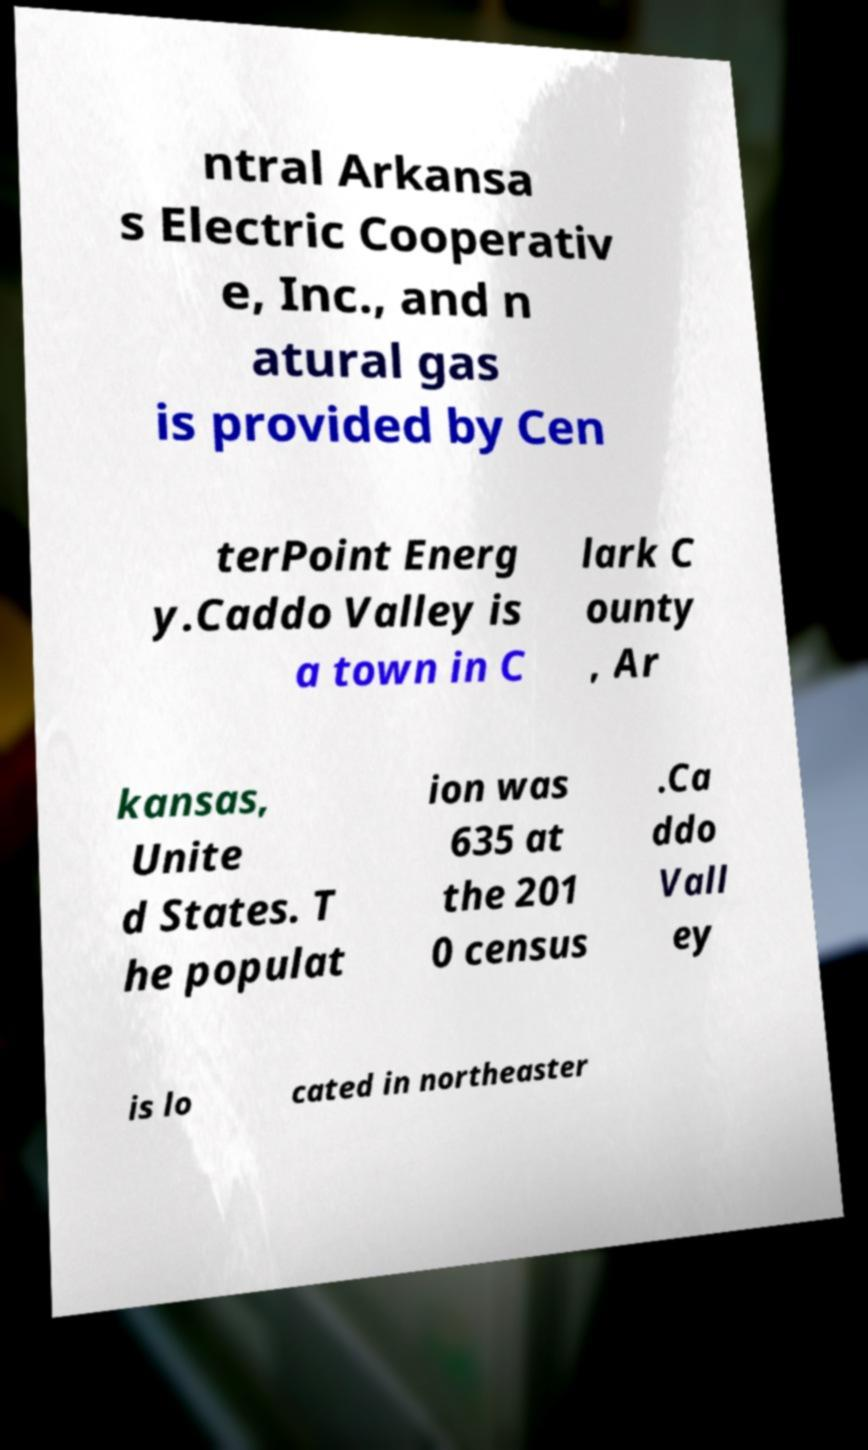There's text embedded in this image that I need extracted. Can you transcribe it verbatim? ntral Arkansa s Electric Cooperativ e, Inc., and n atural gas is provided by Cen terPoint Energ y.Caddo Valley is a town in C lark C ounty , Ar kansas, Unite d States. T he populat ion was 635 at the 201 0 census .Ca ddo Vall ey is lo cated in northeaster 